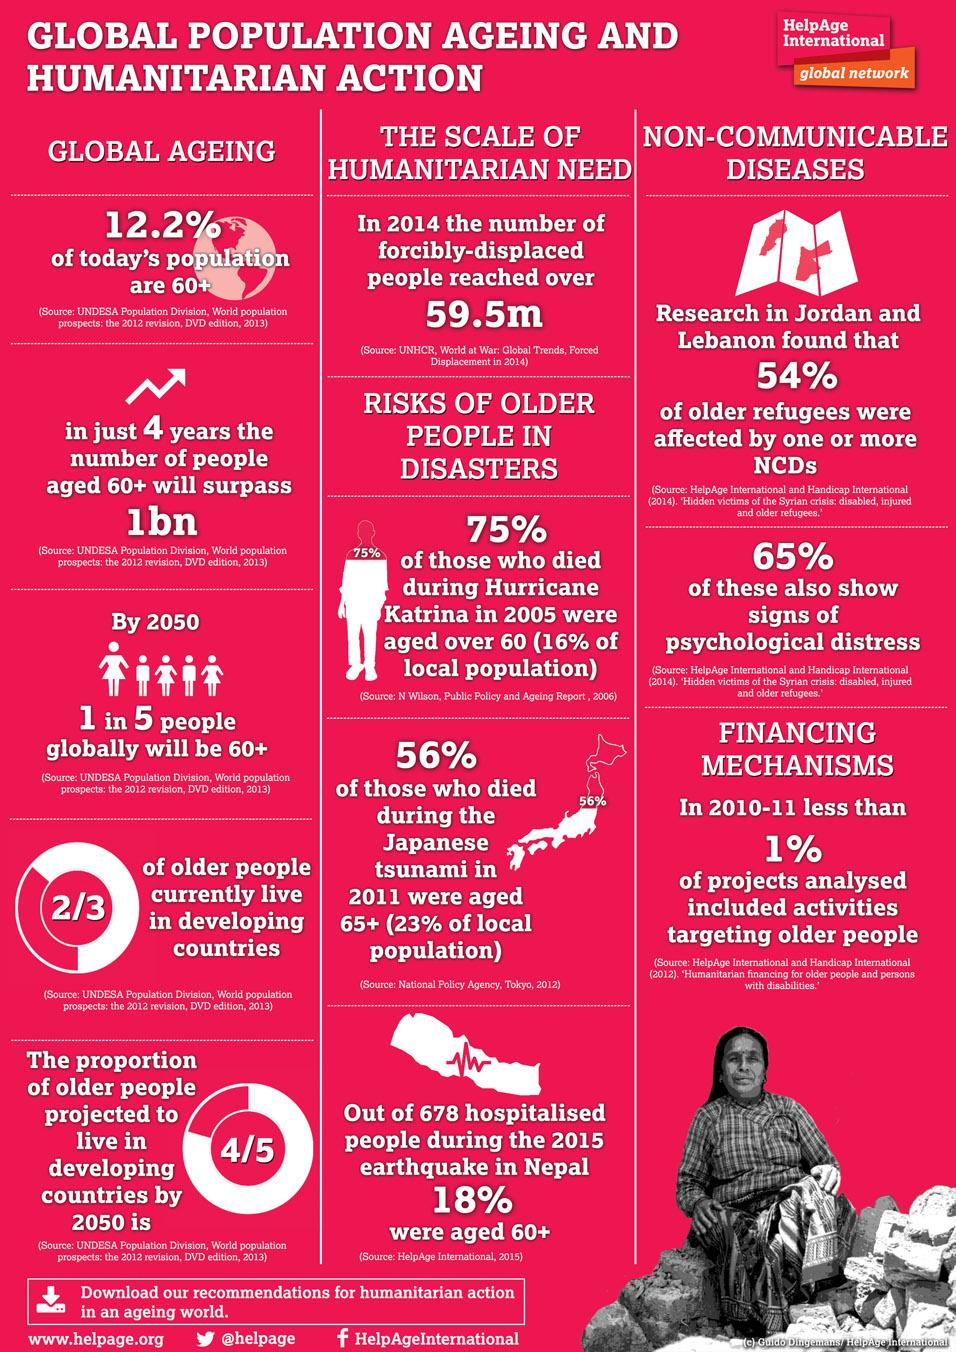Mention a couple of crucial points in this snapshot. The projected ratio of senior citizens in the year 2050 is expected to be 4:5, according to estimates. 